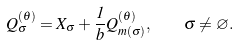Convert formula to latex. <formula><loc_0><loc_0><loc_500><loc_500>Q _ { \sigma } ^ { ( \theta ) } = X _ { \sigma } + \frac { 1 } { b } Q _ { m ( \sigma ) } ^ { ( \theta ) } , \quad \sigma \ne \varnothing .</formula> 